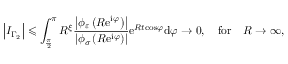Convert formula to latex. <formula><loc_0><loc_0><loc_500><loc_500>\left | I _ { \Gamma _ { 2 } } \right | \leqslant \int _ { \frac { \pi } { 2 } } ^ { \pi } R ^ { \xi } \frac { \left | \phi _ { \varepsilon } \left ( R e ^ { i \varphi } \right ) \right | } { \left | \phi _ { \sigma } \left ( R e ^ { i \varphi } \right ) \right | } e ^ { R t \cos \varphi } d \varphi \rightarrow 0 , \quad f o r \quad R \rightarrow \infty ,</formula> 